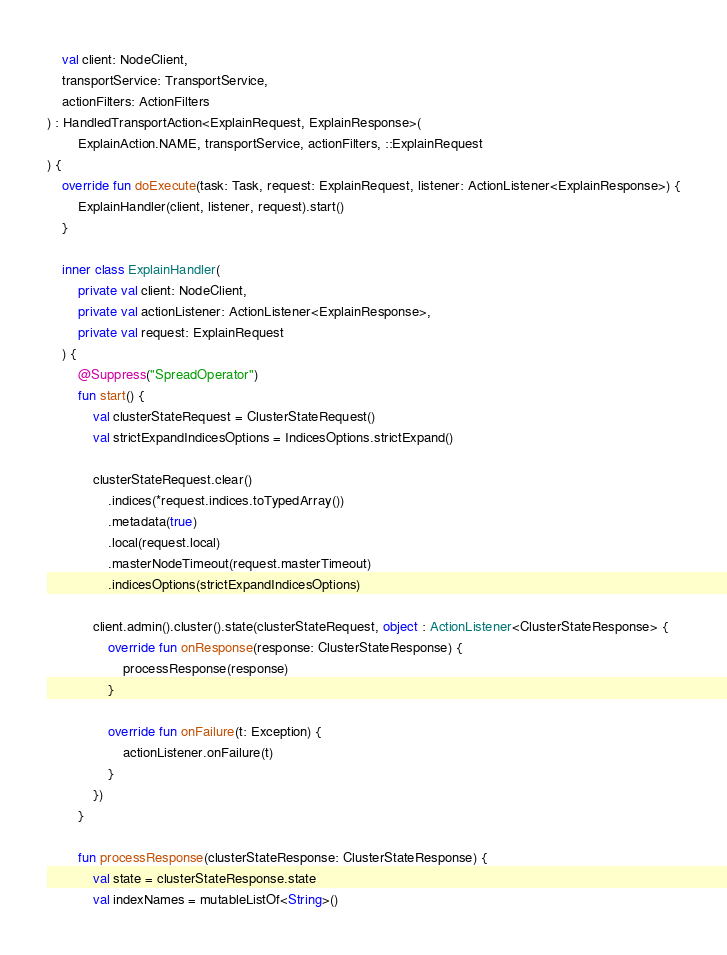Convert code to text. <code><loc_0><loc_0><loc_500><loc_500><_Kotlin_>    val client: NodeClient,
    transportService: TransportService,
    actionFilters: ActionFilters
) : HandledTransportAction<ExplainRequest, ExplainResponse>(
        ExplainAction.NAME, transportService, actionFilters, ::ExplainRequest
) {
    override fun doExecute(task: Task, request: ExplainRequest, listener: ActionListener<ExplainResponse>) {
        ExplainHandler(client, listener, request).start()
    }

    inner class ExplainHandler(
        private val client: NodeClient,
        private val actionListener: ActionListener<ExplainResponse>,
        private val request: ExplainRequest
    ) {
        @Suppress("SpreadOperator")
        fun start() {
            val clusterStateRequest = ClusterStateRequest()
            val strictExpandIndicesOptions = IndicesOptions.strictExpand()

            clusterStateRequest.clear()
                .indices(*request.indices.toTypedArray())
                .metadata(true)
                .local(request.local)
                .masterNodeTimeout(request.masterTimeout)
                .indicesOptions(strictExpandIndicesOptions)

            client.admin().cluster().state(clusterStateRequest, object : ActionListener<ClusterStateResponse> {
                override fun onResponse(response: ClusterStateResponse) {
                    processResponse(response)
                }

                override fun onFailure(t: Exception) {
                    actionListener.onFailure(t)
                }
            })
        }

        fun processResponse(clusterStateResponse: ClusterStateResponse) {
            val state = clusterStateResponse.state
            val indexNames = mutableListOf<String>()</code> 